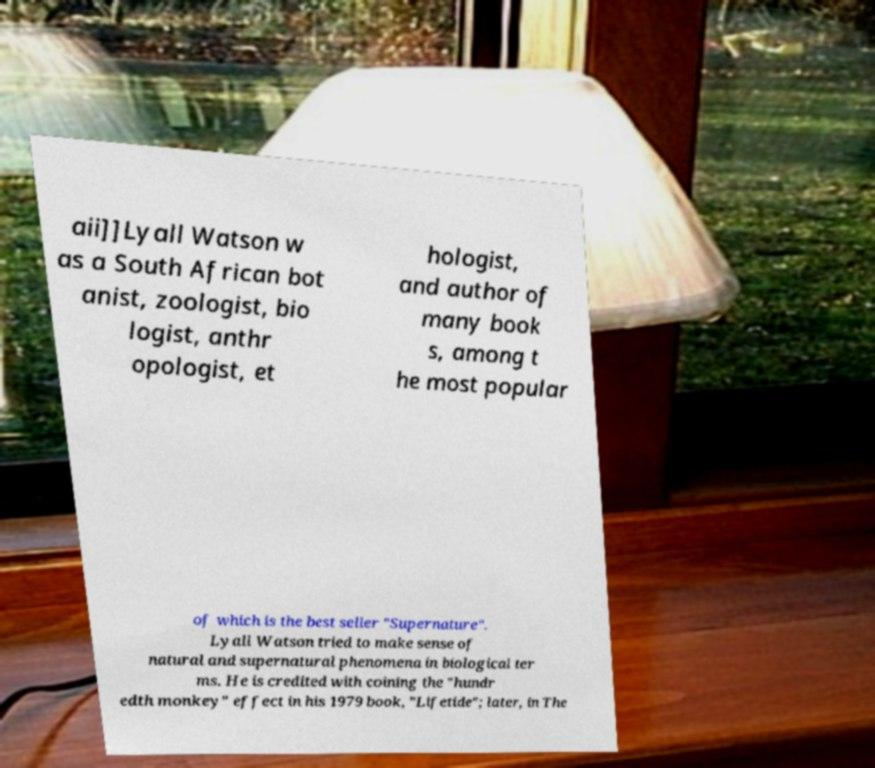Please read and relay the text visible in this image. What does it say? aii]]Lyall Watson w as a South African bot anist, zoologist, bio logist, anthr opologist, et hologist, and author of many book s, among t he most popular of which is the best seller "Supernature". Lyall Watson tried to make sense of natural and supernatural phenomena in biological ter ms. He is credited with coining the "hundr edth monkey" effect in his 1979 book, "Lifetide"; later, in The 